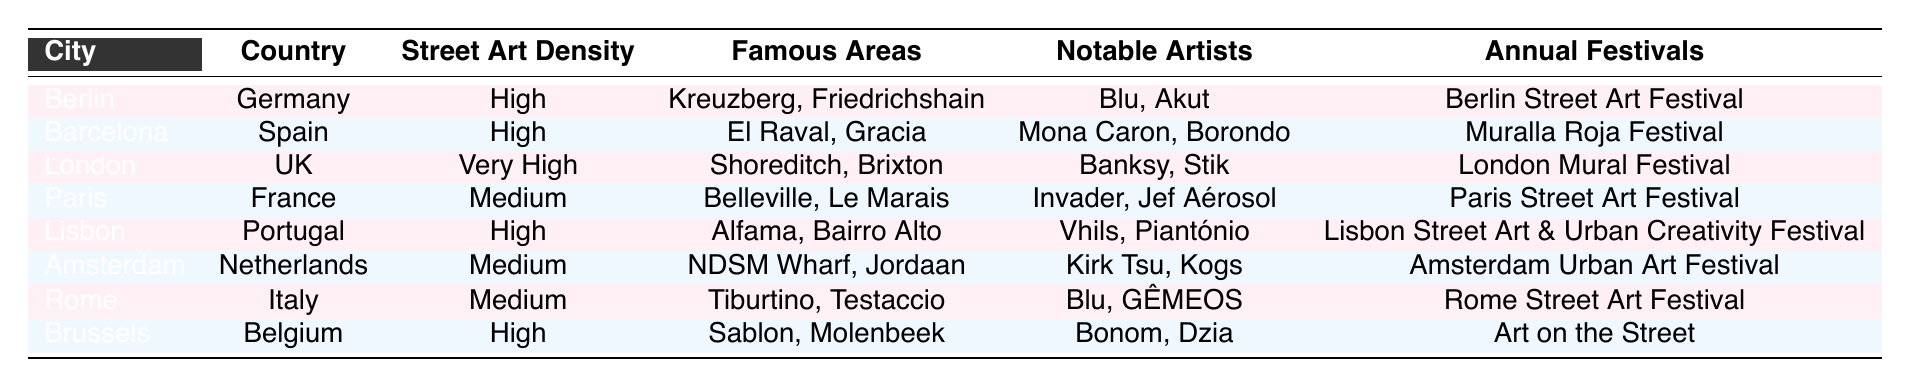What city has the highest street art density? From the table, I can see that London is listed with "Very High" street art density. Comparing the street art densities of all cities, London is the only one that has the "Very High" category, while others range from Medium to High.
Answer: London Which cities are known for having a high street art density? The table shows that both Berlin, Barcelona, and Lisbon have "High" street art density. I can find these cities listed with their corresponding densities in the third column of the table.
Answer: Berlin, Barcelona, Lisbon How many notable artists from Brussels are listed? According to the table, Brussels lists "Bonom" and "Dzia" as notable artists. I just need to count the items in the "Notable Artists" column for Brussels. There are two artists mentioned.
Answer: 2 Is there an annual street art festival held in Paris? The table indicates that Paris has an annual festival called "Paris Street Art Festival." Since this information is taken directly from the annual festivals column for Paris, the answer is yes.
Answer: Yes Which city has notable artists like Vhils and Piantónio, and what is its street art density? Looking at the table, Vhils and Piantónio are listed as notable artists for Lisbon, which has "High" street art density. I have to find the row corresponding to Lisbon and check the details in both the "Notable Artists" and "Street Art Density" columns.
Answer: Lisbon, High What is the average street art density of the cities listed in the table? The cities can be grouped into "Very High" (1 city), "High" (4 cities), and "Medium" (3 cities). Assigning numerical values: Very High = 3, High = 2, Medium = 1. The total would be (3 + 4*2 + 3*1) = (3 + 8 + 3) = 14 from 8 cities, so average is 14/8 = 1.75.
Answer: 1.75 Which city has street art density similar to Amsterdam and what does its notable artist list contain? The table lists Amsterdam with "Medium" street art density, and I can find that the cities with similar density include Paris, Rome, and Amsterdam itself. Checking the notable artists for Amsterdam reveals "Kirk Tsu" and "Kogs." I can list both from the respective column.
Answer: Paris, Rome; Notable Artists: Kirk Tsu, Kogs Are all the cities listed in the table in countries with an annual street art festival? Yes, as I check each city, all four cities have associated annual street art festivals mentioned in the last column. This helps confirm that there is indeed an annual festival for each city in the table, thus the answer is yes.
Answer: Yes 